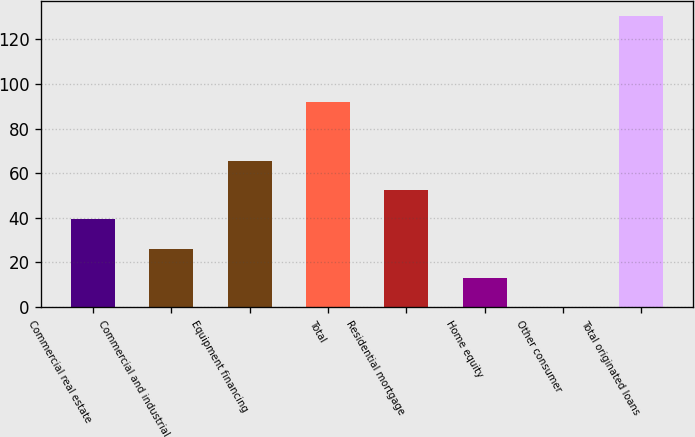Convert chart. <chart><loc_0><loc_0><loc_500><loc_500><bar_chart><fcel>Commercial real estate<fcel>Commercial and industrial<fcel>Equipment financing<fcel>Total<fcel>Residential mortgage<fcel>Home equity<fcel>Other consumer<fcel>Total originated loans<nl><fcel>39.26<fcel>26.24<fcel>65.3<fcel>92<fcel>52.28<fcel>13.22<fcel>0.2<fcel>130.4<nl></chart> 